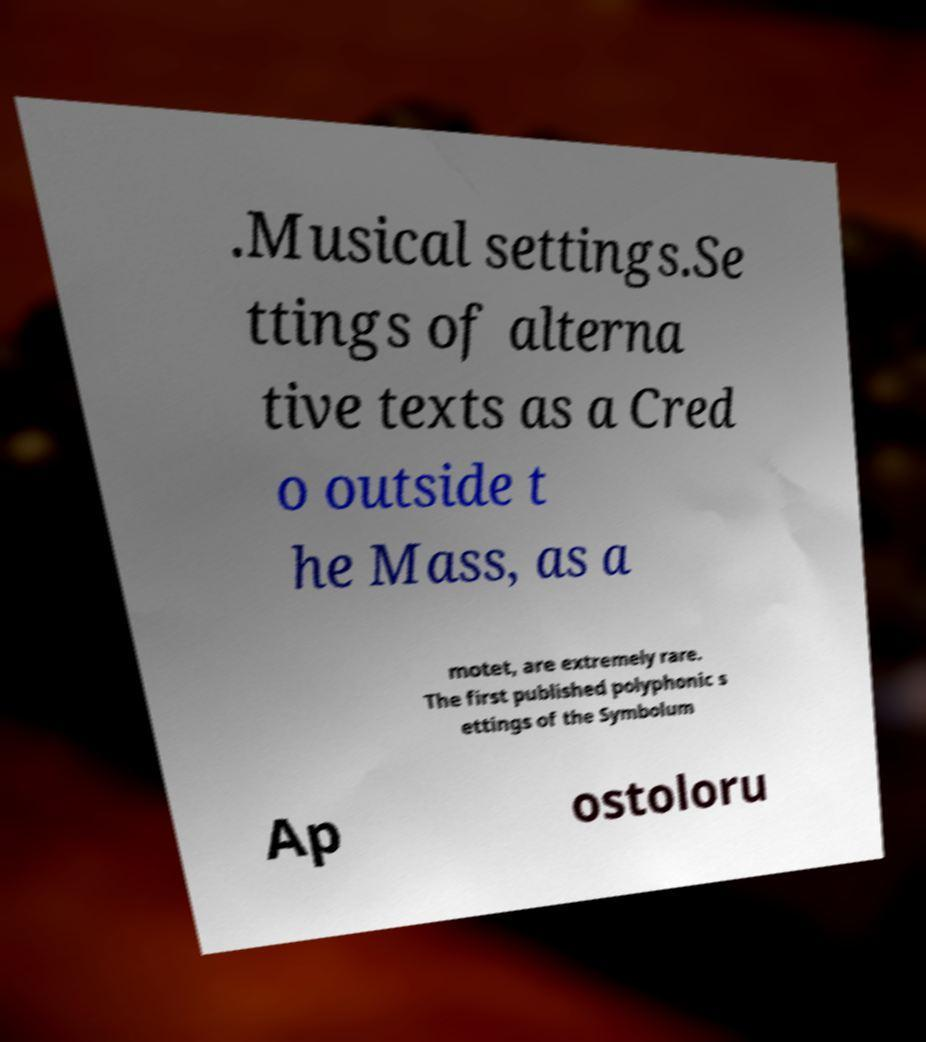Could you extract and type out the text from this image? .Musical settings.Se ttings of alterna tive texts as a Cred o outside t he Mass, as a motet, are extremely rare. The first published polyphonic s ettings of the Symbolum Ap ostoloru 